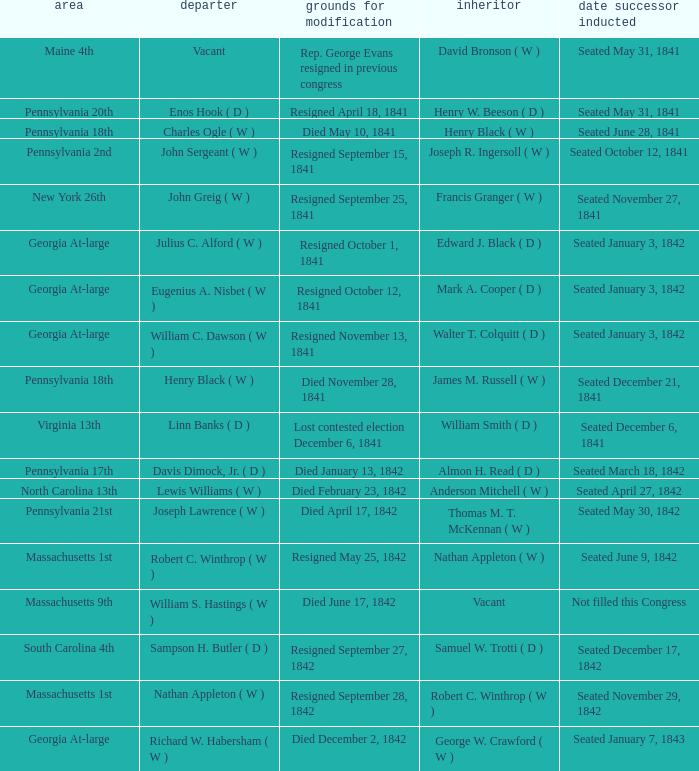Determine the date successor assumed position for pennsylvania's 17th. Seated March 18, 1842. 